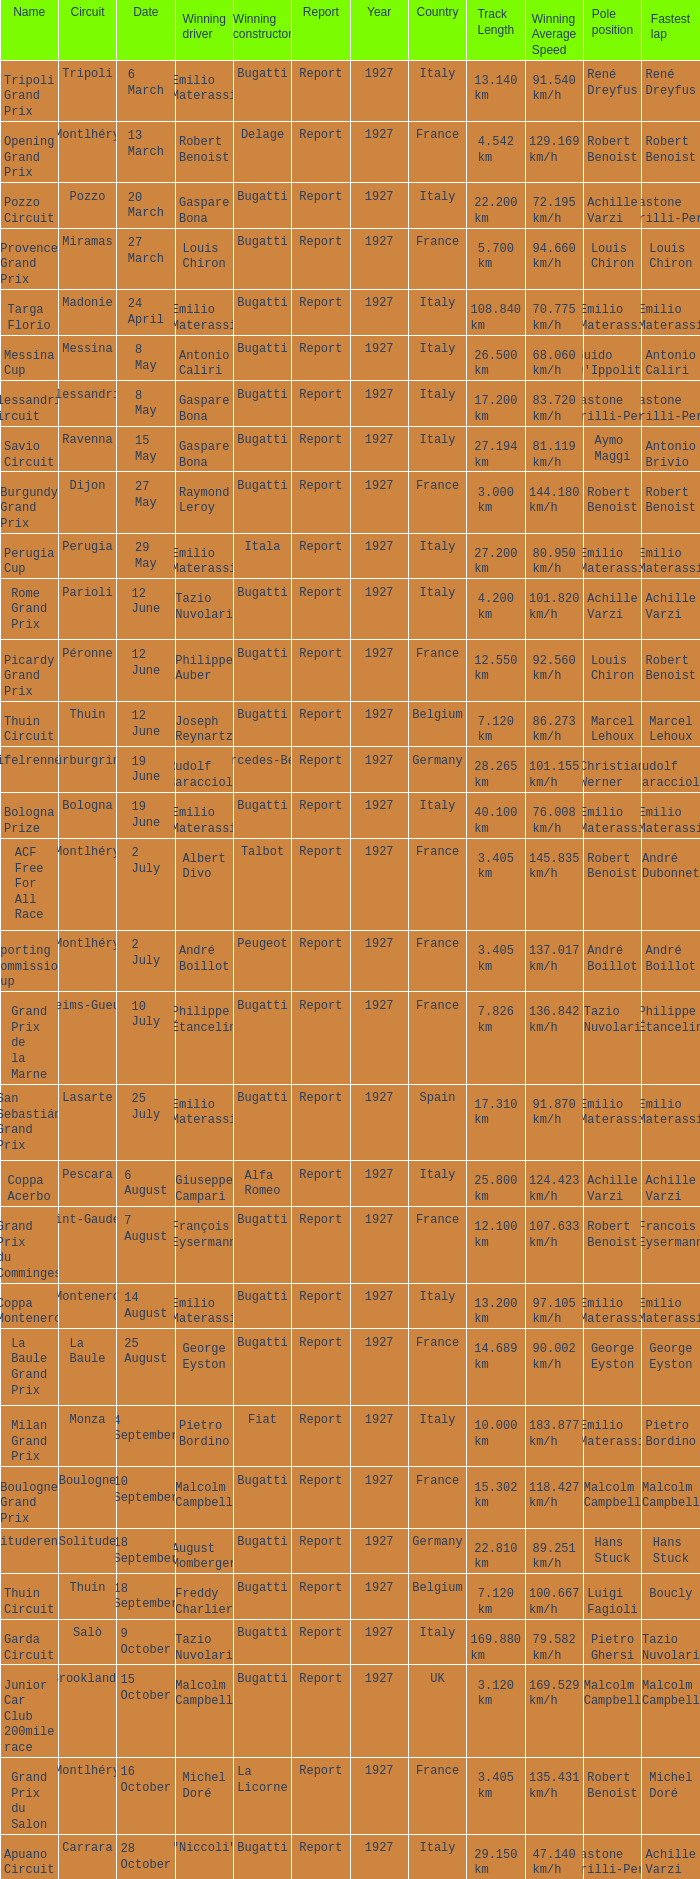Who was the winning constructor at the circuit of parioli? Bugatti. 